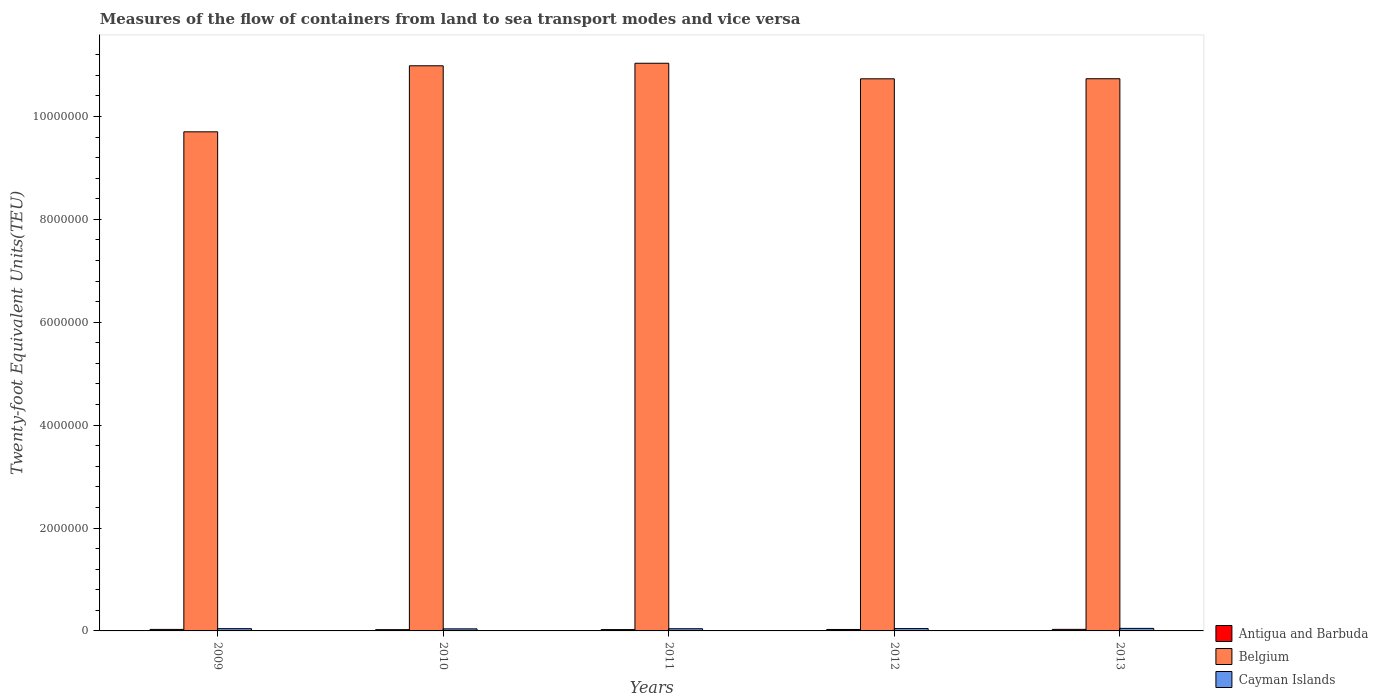How many different coloured bars are there?
Your answer should be compact. 3. Are the number of bars per tick equal to the number of legend labels?
Give a very brief answer. Yes. How many bars are there on the 2nd tick from the right?
Provide a short and direct response. 3. What is the label of the 3rd group of bars from the left?
Offer a terse response. 2011. What is the container port traffic in Cayman Islands in 2013?
Ensure brevity in your answer.  4.94e+04. Across all years, what is the maximum container port traffic in Antigua and Barbuda?
Your response must be concise. 3.02e+04. Across all years, what is the minimum container port traffic in Antigua and Barbuda?
Keep it short and to the point. 2.46e+04. In which year was the container port traffic in Cayman Islands maximum?
Give a very brief answer. 2013. What is the total container port traffic in Cayman Islands in the graph?
Keep it short and to the point. 2.22e+05. What is the difference between the container port traffic in Cayman Islands in 2009 and that in 2011?
Ensure brevity in your answer.  1638. What is the difference between the container port traffic in Belgium in 2009 and the container port traffic in Cayman Islands in 2013?
Keep it short and to the point. 9.65e+06. What is the average container port traffic in Belgium per year?
Provide a short and direct response. 1.06e+07. In the year 2009, what is the difference between the container port traffic in Antigua and Barbuda and container port traffic in Cayman Islands?
Provide a short and direct response. -1.51e+04. What is the ratio of the container port traffic in Cayman Islands in 2009 to that in 2012?
Offer a very short reply. 0.97. Is the container port traffic in Belgium in 2010 less than that in 2012?
Make the answer very short. No. What is the difference between the highest and the second highest container port traffic in Cayman Islands?
Make the answer very short. 3615.85. What is the difference between the highest and the lowest container port traffic in Cayman Islands?
Make the answer very short. 9105.13. What does the 1st bar from the left in 2009 represents?
Your response must be concise. Antigua and Barbuda. What does the 1st bar from the right in 2013 represents?
Your answer should be very brief. Cayman Islands. Is it the case that in every year, the sum of the container port traffic in Belgium and container port traffic in Antigua and Barbuda is greater than the container port traffic in Cayman Islands?
Make the answer very short. Yes. How many bars are there?
Your answer should be compact. 15. Where does the legend appear in the graph?
Make the answer very short. Bottom right. How many legend labels are there?
Ensure brevity in your answer.  3. What is the title of the graph?
Your response must be concise. Measures of the flow of containers from land to sea transport modes and vice versa. What is the label or title of the Y-axis?
Offer a terse response. Twenty-foot Equivalent Units(TEU). What is the Twenty-foot Equivalent Units(TEU) of Antigua and Barbuda in 2009?
Make the answer very short. 2.92e+04. What is the Twenty-foot Equivalent Units(TEU) of Belgium in 2009?
Make the answer very short. 9.70e+06. What is the Twenty-foot Equivalent Units(TEU) in Cayman Islands in 2009?
Make the answer very short. 4.42e+04. What is the Twenty-foot Equivalent Units(TEU) in Antigua and Barbuda in 2010?
Provide a succinct answer. 2.46e+04. What is the Twenty-foot Equivalent Units(TEU) of Belgium in 2010?
Your answer should be compact. 1.10e+07. What is the Twenty-foot Equivalent Units(TEU) of Cayman Islands in 2010?
Ensure brevity in your answer.  4.03e+04. What is the Twenty-foot Equivalent Units(TEU) in Antigua and Barbuda in 2011?
Make the answer very short. 2.60e+04. What is the Twenty-foot Equivalent Units(TEU) of Belgium in 2011?
Give a very brief answer. 1.10e+07. What is the Twenty-foot Equivalent Units(TEU) in Cayman Islands in 2011?
Offer a very short reply. 4.26e+04. What is the Twenty-foot Equivalent Units(TEU) of Antigua and Barbuda in 2012?
Offer a very short reply. 2.80e+04. What is the Twenty-foot Equivalent Units(TEU) of Belgium in 2012?
Provide a short and direct response. 1.07e+07. What is the Twenty-foot Equivalent Units(TEU) in Cayman Islands in 2012?
Provide a short and direct response. 4.58e+04. What is the Twenty-foot Equivalent Units(TEU) of Antigua and Barbuda in 2013?
Offer a very short reply. 3.02e+04. What is the Twenty-foot Equivalent Units(TEU) in Belgium in 2013?
Provide a short and direct response. 1.07e+07. What is the Twenty-foot Equivalent Units(TEU) of Cayman Islands in 2013?
Offer a terse response. 4.94e+04. Across all years, what is the maximum Twenty-foot Equivalent Units(TEU) of Antigua and Barbuda?
Give a very brief answer. 3.02e+04. Across all years, what is the maximum Twenty-foot Equivalent Units(TEU) in Belgium?
Provide a short and direct response. 1.10e+07. Across all years, what is the maximum Twenty-foot Equivalent Units(TEU) of Cayman Islands?
Your answer should be very brief. 4.94e+04. Across all years, what is the minimum Twenty-foot Equivalent Units(TEU) of Antigua and Barbuda?
Provide a succinct answer. 2.46e+04. Across all years, what is the minimum Twenty-foot Equivalent Units(TEU) in Belgium?
Provide a short and direct response. 9.70e+06. Across all years, what is the minimum Twenty-foot Equivalent Units(TEU) in Cayman Islands?
Provide a short and direct response. 4.03e+04. What is the total Twenty-foot Equivalent Units(TEU) in Antigua and Barbuda in the graph?
Provide a short and direct response. 1.38e+05. What is the total Twenty-foot Equivalent Units(TEU) of Belgium in the graph?
Give a very brief answer. 5.32e+07. What is the total Twenty-foot Equivalent Units(TEU) in Cayman Islands in the graph?
Provide a succinct answer. 2.22e+05. What is the difference between the Twenty-foot Equivalent Units(TEU) of Antigua and Barbuda in 2009 and that in 2010?
Ensure brevity in your answer.  4535. What is the difference between the Twenty-foot Equivalent Units(TEU) of Belgium in 2009 and that in 2010?
Provide a succinct answer. -1.28e+06. What is the difference between the Twenty-foot Equivalent Units(TEU) in Cayman Islands in 2009 and that in 2010?
Ensure brevity in your answer.  3934. What is the difference between the Twenty-foot Equivalent Units(TEU) in Antigua and Barbuda in 2009 and that in 2011?
Your answer should be compact. 3131.95. What is the difference between the Twenty-foot Equivalent Units(TEU) in Belgium in 2009 and that in 2011?
Your response must be concise. -1.33e+06. What is the difference between the Twenty-foot Equivalent Units(TEU) of Cayman Islands in 2009 and that in 2011?
Keep it short and to the point. 1638. What is the difference between the Twenty-foot Equivalent Units(TEU) of Antigua and Barbuda in 2009 and that in 2012?
Ensure brevity in your answer.  1180.59. What is the difference between the Twenty-foot Equivalent Units(TEU) in Belgium in 2009 and that in 2012?
Offer a terse response. -1.03e+06. What is the difference between the Twenty-foot Equivalent Units(TEU) in Cayman Islands in 2009 and that in 2012?
Your answer should be compact. -1555.28. What is the difference between the Twenty-foot Equivalent Units(TEU) of Antigua and Barbuda in 2009 and that in 2013?
Your response must be concise. -1028.99. What is the difference between the Twenty-foot Equivalent Units(TEU) in Belgium in 2009 and that in 2013?
Your answer should be compact. -1.03e+06. What is the difference between the Twenty-foot Equivalent Units(TEU) in Cayman Islands in 2009 and that in 2013?
Your answer should be very brief. -5171.13. What is the difference between the Twenty-foot Equivalent Units(TEU) of Antigua and Barbuda in 2010 and that in 2011?
Give a very brief answer. -1403.06. What is the difference between the Twenty-foot Equivalent Units(TEU) in Belgium in 2010 and that in 2011?
Your response must be concise. -4.92e+04. What is the difference between the Twenty-foot Equivalent Units(TEU) of Cayman Islands in 2010 and that in 2011?
Provide a succinct answer. -2296. What is the difference between the Twenty-foot Equivalent Units(TEU) in Antigua and Barbuda in 2010 and that in 2012?
Provide a short and direct response. -3354.41. What is the difference between the Twenty-foot Equivalent Units(TEU) in Belgium in 2010 and that in 2012?
Offer a terse response. 2.53e+05. What is the difference between the Twenty-foot Equivalent Units(TEU) of Cayman Islands in 2010 and that in 2012?
Your answer should be compact. -5489.27. What is the difference between the Twenty-foot Equivalent Units(TEU) in Antigua and Barbuda in 2010 and that in 2013?
Keep it short and to the point. -5563.99. What is the difference between the Twenty-foot Equivalent Units(TEU) of Belgium in 2010 and that in 2013?
Offer a terse response. 2.52e+05. What is the difference between the Twenty-foot Equivalent Units(TEU) of Cayman Islands in 2010 and that in 2013?
Keep it short and to the point. -9105.13. What is the difference between the Twenty-foot Equivalent Units(TEU) of Antigua and Barbuda in 2011 and that in 2012?
Make the answer very short. -1951.35. What is the difference between the Twenty-foot Equivalent Units(TEU) in Belgium in 2011 and that in 2012?
Ensure brevity in your answer.  3.02e+05. What is the difference between the Twenty-foot Equivalent Units(TEU) of Cayman Islands in 2011 and that in 2012?
Give a very brief answer. -3193.28. What is the difference between the Twenty-foot Equivalent Units(TEU) in Antigua and Barbuda in 2011 and that in 2013?
Provide a short and direct response. -4160.94. What is the difference between the Twenty-foot Equivalent Units(TEU) of Belgium in 2011 and that in 2013?
Offer a very short reply. 3.01e+05. What is the difference between the Twenty-foot Equivalent Units(TEU) in Cayman Islands in 2011 and that in 2013?
Offer a terse response. -6809.13. What is the difference between the Twenty-foot Equivalent Units(TEU) of Antigua and Barbuda in 2012 and that in 2013?
Provide a short and direct response. -2209.58. What is the difference between the Twenty-foot Equivalent Units(TEU) of Belgium in 2012 and that in 2013?
Your answer should be compact. -1183.67. What is the difference between the Twenty-foot Equivalent Units(TEU) of Cayman Islands in 2012 and that in 2013?
Provide a short and direct response. -3615.85. What is the difference between the Twenty-foot Equivalent Units(TEU) of Antigua and Barbuda in 2009 and the Twenty-foot Equivalent Units(TEU) of Belgium in 2010?
Provide a short and direct response. -1.10e+07. What is the difference between the Twenty-foot Equivalent Units(TEU) of Antigua and Barbuda in 2009 and the Twenty-foot Equivalent Units(TEU) of Cayman Islands in 2010?
Provide a short and direct response. -1.11e+04. What is the difference between the Twenty-foot Equivalent Units(TEU) of Belgium in 2009 and the Twenty-foot Equivalent Units(TEU) of Cayman Islands in 2010?
Your answer should be compact. 9.66e+06. What is the difference between the Twenty-foot Equivalent Units(TEU) in Antigua and Barbuda in 2009 and the Twenty-foot Equivalent Units(TEU) in Belgium in 2011?
Make the answer very short. -1.10e+07. What is the difference between the Twenty-foot Equivalent Units(TEU) of Antigua and Barbuda in 2009 and the Twenty-foot Equivalent Units(TEU) of Cayman Islands in 2011?
Offer a terse response. -1.34e+04. What is the difference between the Twenty-foot Equivalent Units(TEU) of Belgium in 2009 and the Twenty-foot Equivalent Units(TEU) of Cayman Islands in 2011?
Your answer should be very brief. 9.66e+06. What is the difference between the Twenty-foot Equivalent Units(TEU) of Antigua and Barbuda in 2009 and the Twenty-foot Equivalent Units(TEU) of Belgium in 2012?
Offer a terse response. -1.07e+07. What is the difference between the Twenty-foot Equivalent Units(TEU) of Antigua and Barbuda in 2009 and the Twenty-foot Equivalent Units(TEU) of Cayman Islands in 2012?
Offer a terse response. -1.66e+04. What is the difference between the Twenty-foot Equivalent Units(TEU) in Belgium in 2009 and the Twenty-foot Equivalent Units(TEU) in Cayman Islands in 2012?
Make the answer very short. 9.66e+06. What is the difference between the Twenty-foot Equivalent Units(TEU) in Antigua and Barbuda in 2009 and the Twenty-foot Equivalent Units(TEU) in Belgium in 2013?
Your response must be concise. -1.07e+07. What is the difference between the Twenty-foot Equivalent Units(TEU) in Antigua and Barbuda in 2009 and the Twenty-foot Equivalent Units(TEU) in Cayman Islands in 2013?
Your response must be concise. -2.02e+04. What is the difference between the Twenty-foot Equivalent Units(TEU) of Belgium in 2009 and the Twenty-foot Equivalent Units(TEU) of Cayman Islands in 2013?
Make the answer very short. 9.65e+06. What is the difference between the Twenty-foot Equivalent Units(TEU) of Antigua and Barbuda in 2010 and the Twenty-foot Equivalent Units(TEU) of Belgium in 2011?
Your response must be concise. -1.10e+07. What is the difference between the Twenty-foot Equivalent Units(TEU) in Antigua and Barbuda in 2010 and the Twenty-foot Equivalent Units(TEU) in Cayman Islands in 2011?
Your answer should be very brief. -1.80e+04. What is the difference between the Twenty-foot Equivalent Units(TEU) of Belgium in 2010 and the Twenty-foot Equivalent Units(TEU) of Cayman Islands in 2011?
Your response must be concise. 1.09e+07. What is the difference between the Twenty-foot Equivalent Units(TEU) of Antigua and Barbuda in 2010 and the Twenty-foot Equivalent Units(TEU) of Belgium in 2012?
Give a very brief answer. -1.07e+07. What is the difference between the Twenty-foot Equivalent Units(TEU) in Antigua and Barbuda in 2010 and the Twenty-foot Equivalent Units(TEU) in Cayman Islands in 2012?
Your response must be concise. -2.12e+04. What is the difference between the Twenty-foot Equivalent Units(TEU) of Belgium in 2010 and the Twenty-foot Equivalent Units(TEU) of Cayman Islands in 2012?
Ensure brevity in your answer.  1.09e+07. What is the difference between the Twenty-foot Equivalent Units(TEU) of Antigua and Barbuda in 2010 and the Twenty-foot Equivalent Units(TEU) of Belgium in 2013?
Offer a terse response. -1.07e+07. What is the difference between the Twenty-foot Equivalent Units(TEU) of Antigua and Barbuda in 2010 and the Twenty-foot Equivalent Units(TEU) of Cayman Islands in 2013?
Offer a very short reply. -2.48e+04. What is the difference between the Twenty-foot Equivalent Units(TEU) of Belgium in 2010 and the Twenty-foot Equivalent Units(TEU) of Cayman Islands in 2013?
Make the answer very short. 1.09e+07. What is the difference between the Twenty-foot Equivalent Units(TEU) of Antigua and Barbuda in 2011 and the Twenty-foot Equivalent Units(TEU) of Belgium in 2012?
Make the answer very short. -1.07e+07. What is the difference between the Twenty-foot Equivalent Units(TEU) in Antigua and Barbuda in 2011 and the Twenty-foot Equivalent Units(TEU) in Cayman Islands in 2012?
Provide a succinct answer. -1.98e+04. What is the difference between the Twenty-foot Equivalent Units(TEU) of Belgium in 2011 and the Twenty-foot Equivalent Units(TEU) of Cayman Islands in 2012?
Offer a very short reply. 1.10e+07. What is the difference between the Twenty-foot Equivalent Units(TEU) of Antigua and Barbuda in 2011 and the Twenty-foot Equivalent Units(TEU) of Belgium in 2013?
Your response must be concise. -1.07e+07. What is the difference between the Twenty-foot Equivalent Units(TEU) in Antigua and Barbuda in 2011 and the Twenty-foot Equivalent Units(TEU) in Cayman Islands in 2013?
Offer a very short reply. -2.34e+04. What is the difference between the Twenty-foot Equivalent Units(TEU) in Belgium in 2011 and the Twenty-foot Equivalent Units(TEU) in Cayman Islands in 2013?
Offer a very short reply. 1.10e+07. What is the difference between the Twenty-foot Equivalent Units(TEU) of Antigua and Barbuda in 2012 and the Twenty-foot Equivalent Units(TEU) of Belgium in 2013?
Keep it short and to the point. -1.07e+07. What is the difference between the Twenty-foot Equivalent Units(TEU) in Antigua and Barbuda in 2012 and the Twenty-foot Equivalent Units(TEU) in Cayman Islands in 2013?
Provide a short and direct response. -2.14e+04. What is the difference between the Twenty-foot Equivalent Units(TEU) of Belgium in 2012 and the Twenty-foot Equivalent Units(TEU) of Cayman Islands in 2013?
Keep it short and to the point. 1.07e+07. What is the average Twenty-foot Equivalent Units(TEU) of Antigua and Barbuda per year?
Provide a short and direct response. 2.76e+04. What is the average Twenty-foot Equivalent Units(TEU) of Belgium per year?
Offer a terse response. 1.06e+07. What is the average Twenty-foot Equivalent Units(TEU) in Cayman Islands per year?
Offer a terse response. 4.44e+04. In the year 2009, what is the difference between the Twenty-foot Equivalent Units(TEU) in Antigua and Barbuda and Twenty-foot Equivalent Units(TEU) in Belgium?
Provide a succinct answer. -9.67e+06. In the year 2009, what is the difference between the Twenty-foot Equivalent Units(TEU) in Antigua and Barbuda and Twenty-foot Equivalent Units(TEU) in Cayman Islands?
Provide a short and direct response. -1.51e+04. In the year 2009, what is the difference between the Twenty-foot Equivalent Units(TEU) of Belgium and Twenty-foot Equivalent Units(TEU) of Cayman Islands?
Make the answer very short. 9.66e+06. In the year 2010, what is the difference between the Twenty-foot Equivalent Units(TEU) in Antigua and Barbuda and Twenty-foot Equivalent Units(TEU) in Belgium?
Keep it short and to the point. -1.10e+07. In the year 2010, what is the difference between the Twenty-foot Equivalent Units(TEU) of Antigua and Barbuda and Twenty-foot Equivalent Units(TEU) of Cayman Islands?
Your answer should be compact. -1.57e+04. In the year 2010, what is the difference between the Twenty-foot Equivalent Units(TEU) in Belgium and Twenty-foot Equivalent Units(TEU) in Cayman Islands?
Your response must be concise. 1.09e+07. In the year 2011, what is the difference between the Twenty-foot Equivalent Units(TEU) of Antigua and Barbuda and Twenty-foot Equivalent Units(TEU) of Belgium?
Provide a short and direct response. -1.10e+07. In the year 2011, what is the difference between the Twenty-foot Equivalent Units(TEU) of Antigua and Barbuda and Twenty-foot Equivalent Units(TEU) of Cayman Islands?
Provide a short and direct response. -1.66e+04. In the year 2011, what is the difference between the Twenty-foot Equivalent Units(TEU) in Belgium and Twenty-foot Equivalent Units(TEU) in Cayman Islands?
Offer a terse response. 1.10e+07. In the year 2012, what is the difference between the Twenty-foot Equivalent Units(TEU) of Antigua and Barbuda and Twenty-foot Equivalent Units(TEU) of Belgium?
Your response must be concise. -1.07e+07. In the year 2012, what is the difference between the Twenty-foot Equivalent Units(TEU) of Antigua and Barbuda and Twenty-foot Equivalent Units(TEU) of Cayman Islands?
Your answer should be very brief. -1.78e+04. In the year 2012, what is the difference between the Twenty-foot Equivalent Units(TEU) in Belgium and Twenty-foot Equivalent Units(TEU) in Cayman Islands?
Ensure brevity in your answer.  1.07e+07. In the year 2013, what is the difference between the Twenty-foot Equivalent Units(TEU) of Antigua and Barbuda and Twenty-foot Equivalent Units(TEU) of Belgium?
Provide a short and direct response. -1.07e+07. In the year 2013, what is the difference between the Twenty-foot Equivalent Units(TEU) of Antigua and Barbuda and Twenty-foot Equivalent Units(TEU) of Cayman Islands?
Keep it short and to the point. -1.92e+04. In the year 2013, what is the difference between the Twenty-foot Equivalent Units(TEU) in Belgium and Twenty-foot Equivalent Units(TEU) in Cayman Islands?
Make the answer very short. 1.07e+07. What is the ratio of the Twenty-foot Equivalent Units(TEU) of Antigua and Barbuda in 2009 to that in 2010?
Your answer should be very brief. 1.18. What is the ratio of the Twenty-foot Equivalent Units(TEU) in Belgium in 2009 to that in 2010?
Offer a very short reply. 0.88. What is the ratio of the Twenty-foot Equivalent Units(TEU) in Cayman Islands in 2009 to that in 2010?
Give a very brief answer. 1.1. What is the ratio of the Twenty-foot Equivalent Units(TEU) in Antigua and Barbuda in 2009 to that in 2011?
Make the answer very short. 1.12. What is the ratio of the Twenty-foot Equivalent Units(TEU) of Belgium in 2009 to that in 2011?
Your response must be concise. 0.88. What is the ratio of the Twenty-foot Equivalent Units(TEU) in Antigua and Barbuda in 2009 to that in 2012?
Keep it short and to the point. 1.04. What is the ratio of the Twenty-foot Equivalent Units(TEU) in Belgium in 2009 to that in 2012?
Offer a terse response. 0.9. What is the ratio of the Twenty-foot Equivalent Units(TEU) of Antigua and Barbuda in 2009 to that in 2013?
Provide a succinct answer. 0.97. What is the ratio of the Twenty-foot Equivalent Units(TEU) of Belgium in 2009 to that in 2013?
Ensure brevity in your answer.  0.9. What is the ratio of the Twenty-foot Equivalent Units(TEU) of Cayman Islands in 2009 to that in 2013?
Make the answer very short. 0.9. What is the ratio of the Twenty-foot Equivalent Units(TEU) in Antigua and Barbuda in 2010 to that in 2011?
Give a very brief answer. 0.95. What is the ratio of the Twenty-foot Equivalent Units(TEU) of Belgium in 2010 to that in 2011?
Your answer should be compact. 1. What is the ratio of the Twenty-foot Equivalent Units(TEU) in Cayman Islands in 2010 to that in 2011?
Make the answer very short. 0.95. What is the ratio of the Twenty-foot Equivalent Units(TEU) in Antigua and Barbuda in 2010 to that in 2012?
Give a very brief answer. 0.88. What is the ratio of the Twenty-foot Equivalent Units(TEU) in Belgium in 2010 to that in 2012?
Provide a succinct answer. 1.02. What is the ratio of the Twenty-foot Equivalent Units(TEU) of Cayman Islands in 2010 to that in 2012?
Your answer should be very brief. 0.88. What is the ratio of the Twenty-foot Equivalent Units(TEU) of Antigua and Barbuda in 2010 to that in 2013?
Offer a terse response. 0.82. What is the ratio of the Twenty-foot Equivalent Units(TEU) of Belgium in 2010 to that in 2013?
Your answer should be compact. 1.02. What is the ratio of the Twenty-foot Equivalent Units(TEU) of Cayman Islands in 2010 to that in 2013?
Your answer should be compact. 0.82. What is the ratio of the Twenty-foot Equivalent Units(TEU) of Antigua and Barbuda in 2011 to that in 2012?
Keep it short and to the point. 0.93. What is the ratio of the Twenty-foot Equivalent Units(TEU) in Belgium in 2011 to that in 2012?
Ensure brevity in your answer.  1.03. What is the ratio of the Twenty-foot Equivalent Units(TEU) in Cayman Islands in 2011 to that in 2012?
Your answer should be very brief. 0.93. What is the ratio of the Twenty-foot Equivalent Units(TEU) in Antigua and Barbuda in 2011 to that in 2013?
Provide a short and direct response. 0.86. What is the ratio of the Twenty-foot Equivalent Units(TEU) of Belgium in 2011 to that in 2013?
Provide a short and direct response. 1.03. What is the ratio of the Twenty-foot Equivalent Units(TEU) of Cayman Islands in 2011 to that in 2013?
Your response must be concise. 0.86. What is the ratio of the Twenty-foot Equivalent Units(TEU) in Antigua and Barbuda in 2012 to that in 2013?
Your answer should be very brief. 0.93. What is the ratio of the Twenty-foot Equivalent Units(TEU) of Cayman Islands in 2012 to that in 2013?
Offer a very short reply. 0.93. What is the difference between the highest and the second highest Twenty-foot Equivalent Units(TEU) of Antigua and Barbuda?
Give a very brief answer. 1028.99. What is the difference between the highest and the second highest Twenty-foot Equivalent Units(TEU) of Belgium?
Offer a terse response. 4.92e+04. What is the difference between the highest and the second highest Twenty-foot Equivalent Units(TEU) of Cayman Islands?
Offer a terse response. 3615.85. What is the difference between the highest and the lowest Twenty-foot Equivalent Units(TEU) of Antigua and Barbuda?
Ensure brevity in your answer.  5563.99. What is the difference between the highest and the lowest Twenty-foot Equivalent Units(TEU) in Belgium?
Your answer should be very brief. 1.33e+06. What is the difference between the highest and the lowest Twenty-foot Equivalent Units(TEU) of Cayman Islands?
Keep it short and to the point. 9105.13. 